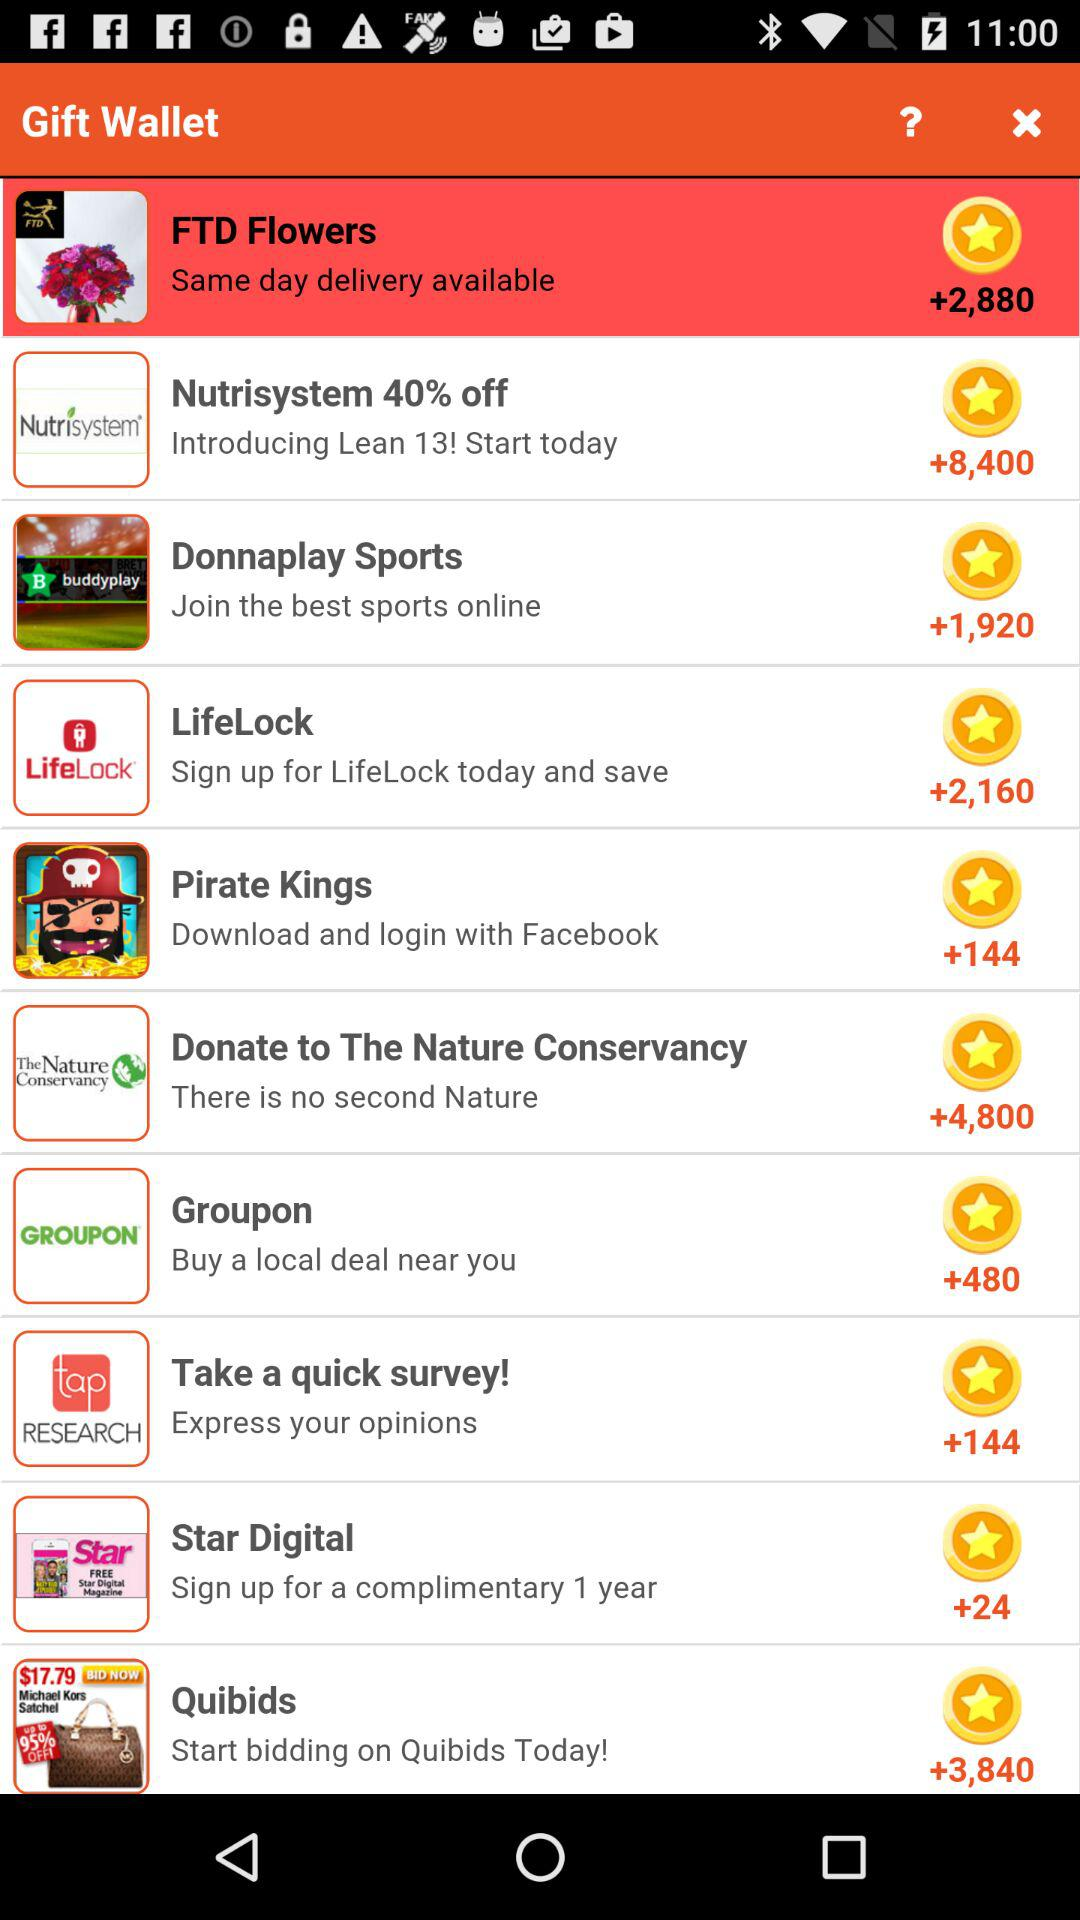How much is the discount on nutrisystem? The discount on nutrisystem is 40%. 